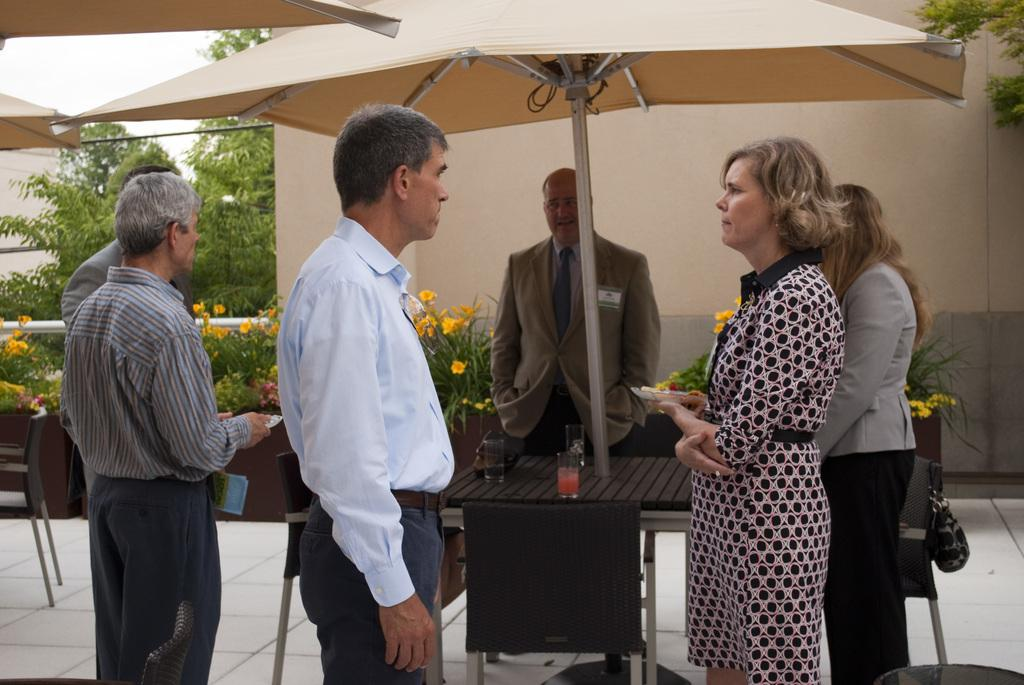What are the people in the image doing? The people in the image are standing in the center. What furniture is present in the image? There is a table and chairs in the image. What can be seen in the background of the image? There is a wall and trees in the background of the image. How many lizards are sitting on the table in the image? There are no lizards present in the image. What type of loss is being experienced by the man in the image? There is no man or indication of loss in the image. 